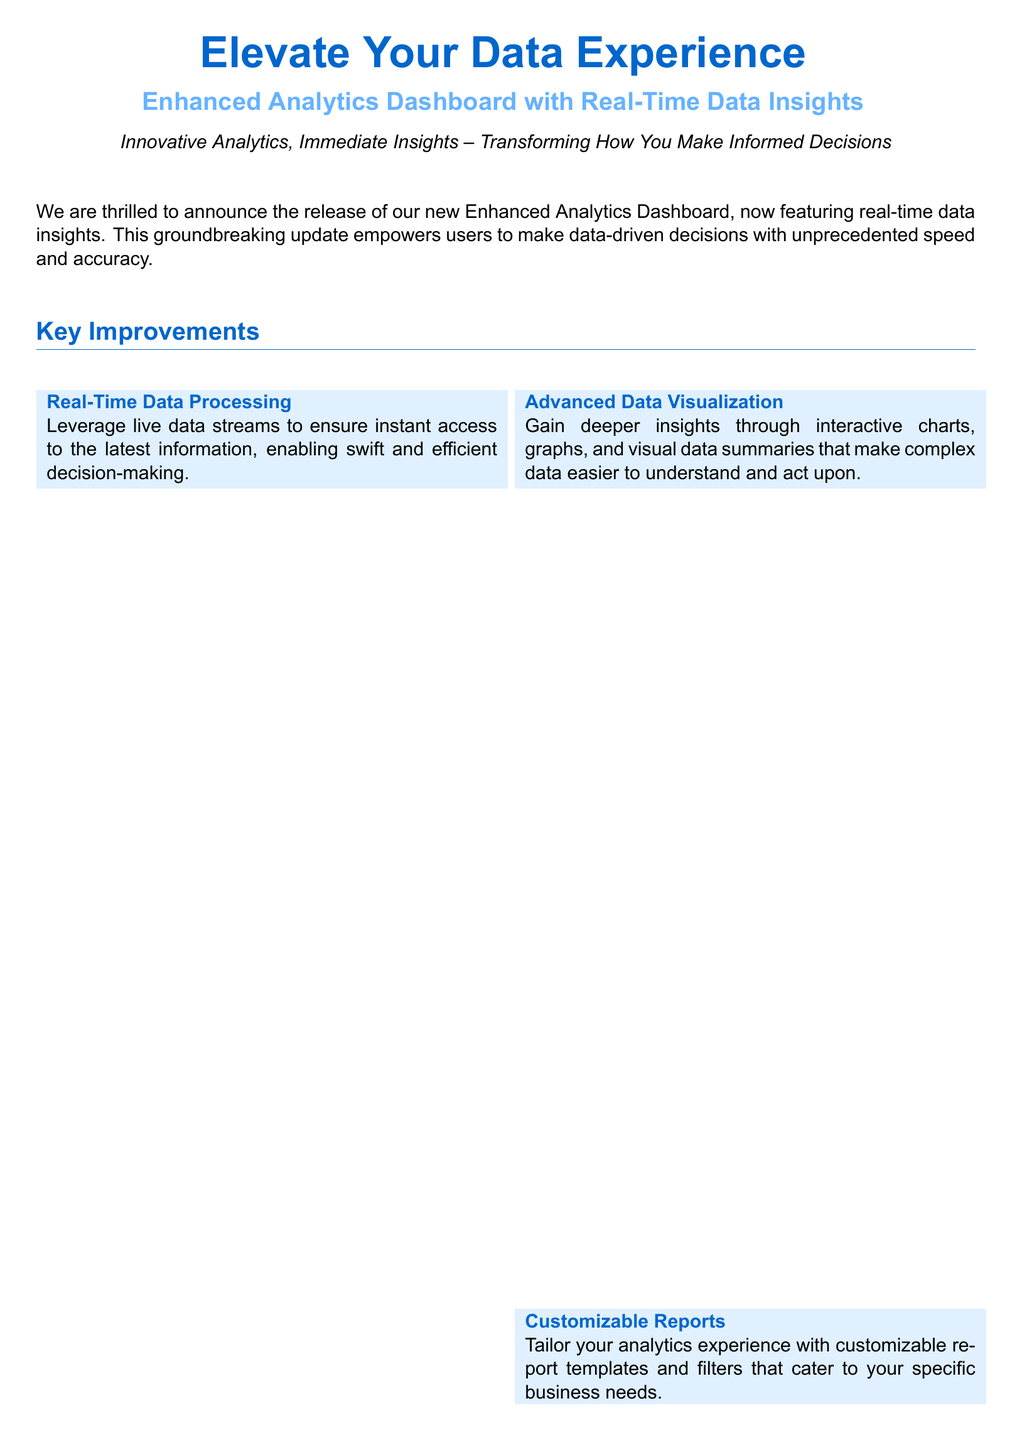What is the title of the new feature? The title of the new feature is mentioned prominently at the beginning of the document.
Answer: Enhanced Analytics Dashboard with Real-Time Data Insights Who is the CTO quoted in the Customer Impact section? The CTO is cited in the Customer Impact section, providing a statement about the feature.
Answer: Lisa Morgan What kind of support does the vendor provide? The document states the type of support available with the new feature release.
Answer: 24/7 technical support How many key improvements are listed in the document? The document explicitly mentions how many key improvements are highlighted.
Answer: Four What is one benefit of the real-time data processing feature? The document describes at least one advantage of using real-time data processing.
Answer: Instant access to the latest information What are users able to do with customizable reports? The document explains the purpose of customizable reports in the analytics dashboard.
Answer: Tailor your analytics experience Which company does John Baker represent? The document attributes a statement to a representative of a particular company in the Customer Impact section.
Answer: Global Solutions Ltd What is the main theme of the press release? The main theme is encapsulated in the opening statement, reflecting the overall goal of the feature.
Answer: Transforming How You Make Informed Decisions 